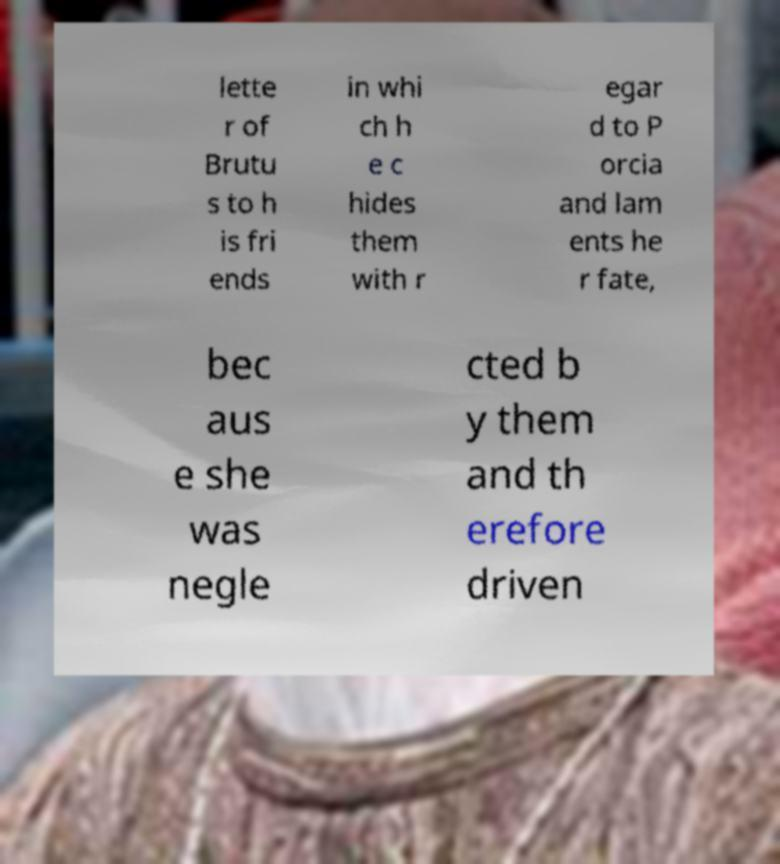I need the written content from this picture converted into text. Can you do that? lette r of Brutu s to h is fri ends in whi ch h e c hides them with r egar d to P orcia and lam ents he r fate, bec aus e she was negle cted b y them and th erefore driven 